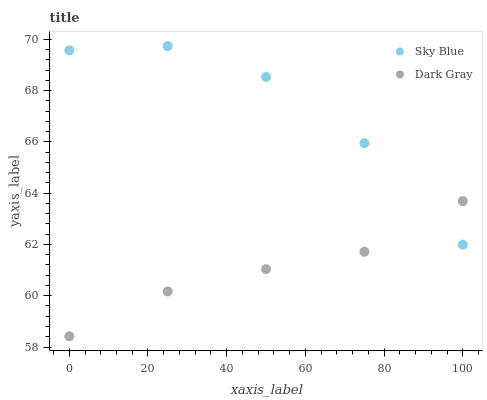Does Dark Gray have the minimum area under the curve?
Answer yes or no. Yes. Does Sky Blue have the maximum area under the curve?
Answer yes or no. Yes. Does Sky Blue have the minimum area under the curve?
Answer yes or no. No. Is Dark Gray the smoothest?
Answer yes or no. Yes. Is Sky Blue the roughest?
Answer yes or no. Yes. Is Sky Blue the smoothest?
Answer yes or no. No. Does Dark Gray have the lowest value?
Answer yes or no. Yes. Does Sky Blue have the lowest value?
Answer yes or no. No. Does Sky Blue have the highest value?
Answer yes or no. Yes. Does Sky Blue intersect Dark Gray?
Answer yes or no. Yes. Is Sky Blue less than Dark Gray?
Answer yes or no. No. Is Sky Blue greater than Dark Gray?
Answer yes or no. No. 